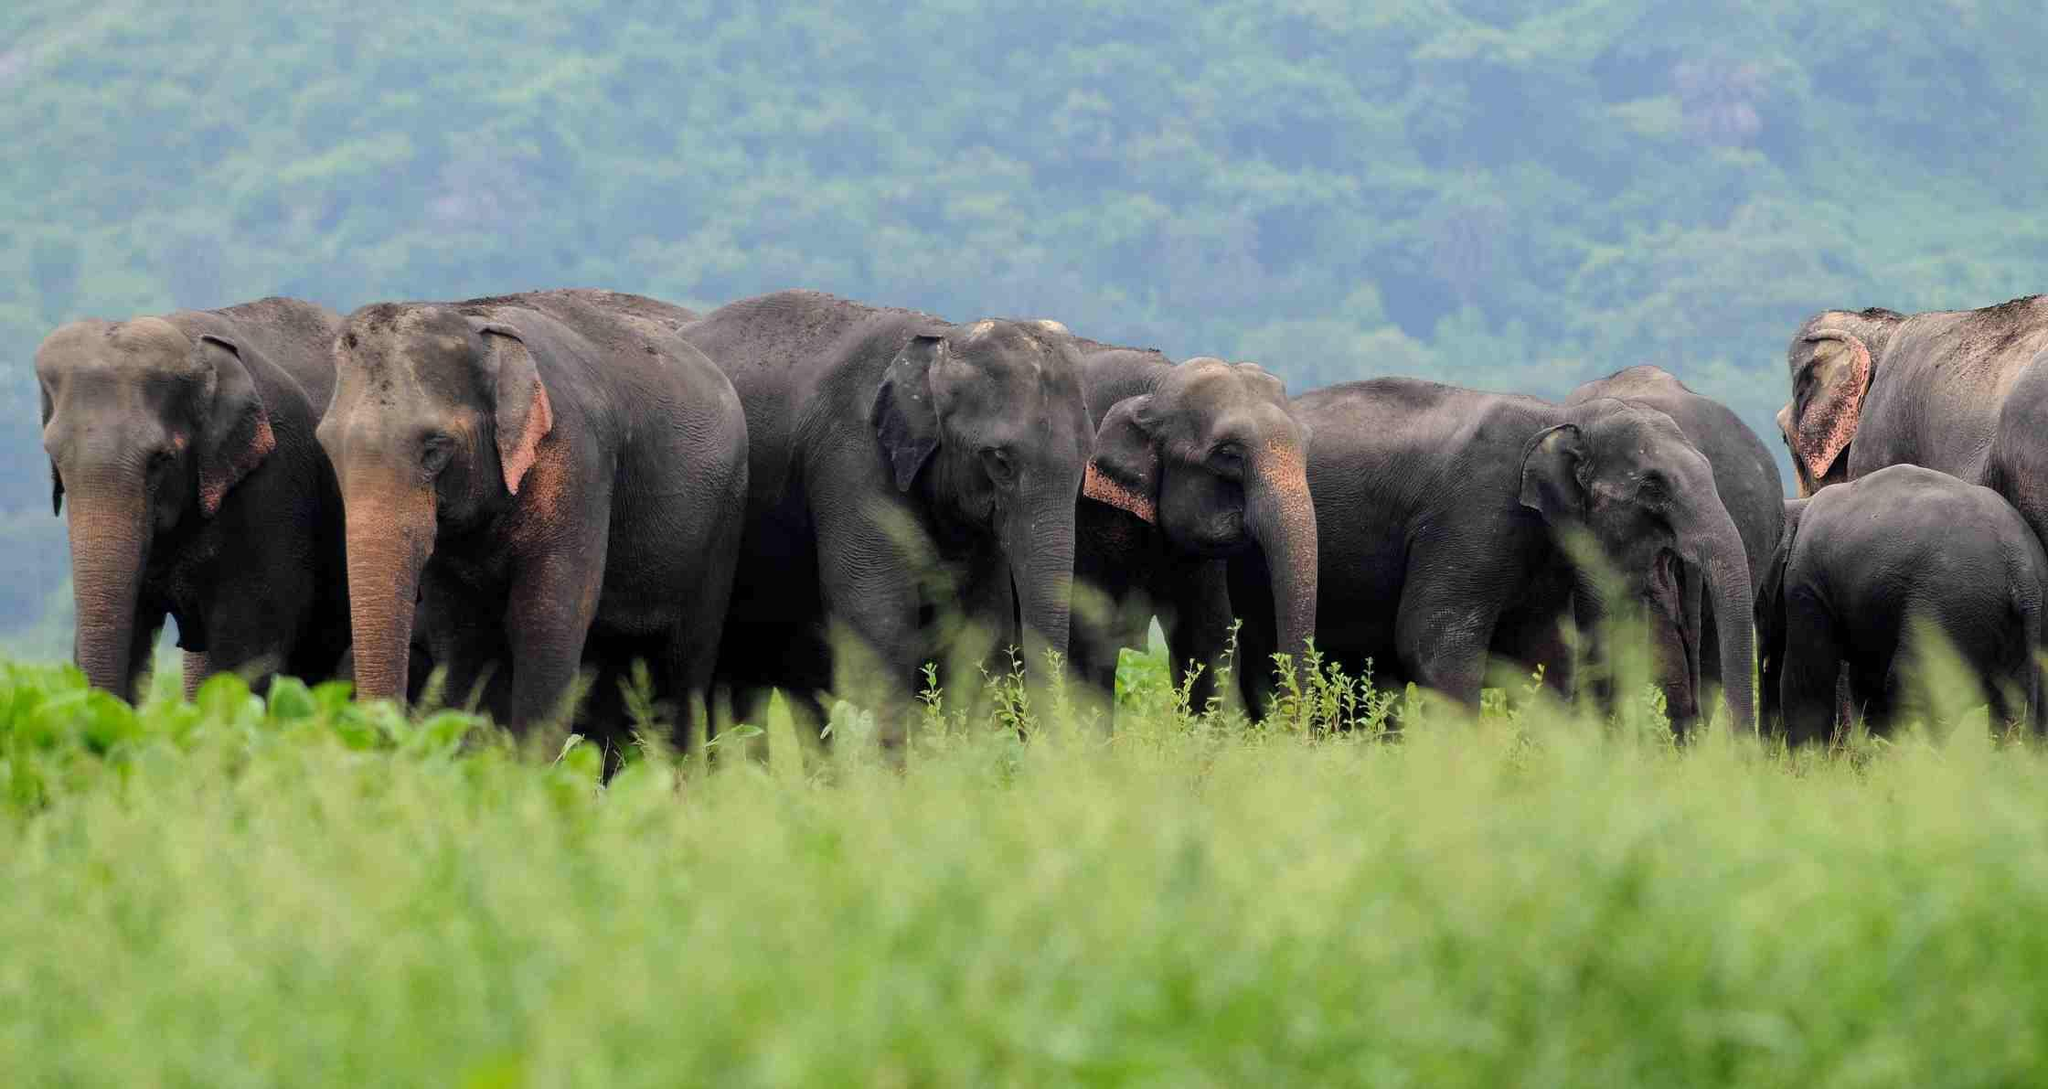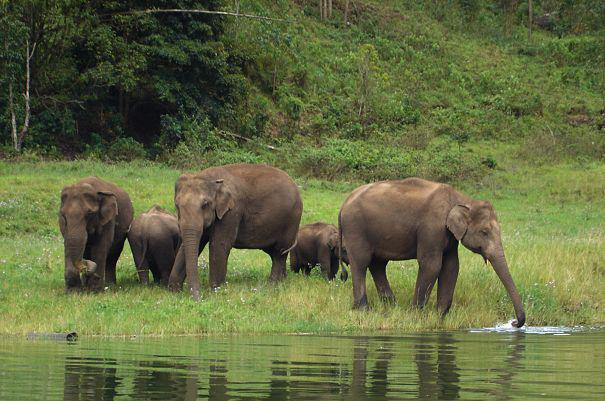The first image is the image on the left, the second image is the image on the right. For the images shown, is this caption "There are no more than three elephants in the image on the right." true? Answer yes or no. No. The first image is the image on the left, the second image is the image on the right. For the images displayed, is the sentence "Elephants are eating pumpkins, another elephant has a baby holding her tail" factually correct? Answer yes or no. No. 